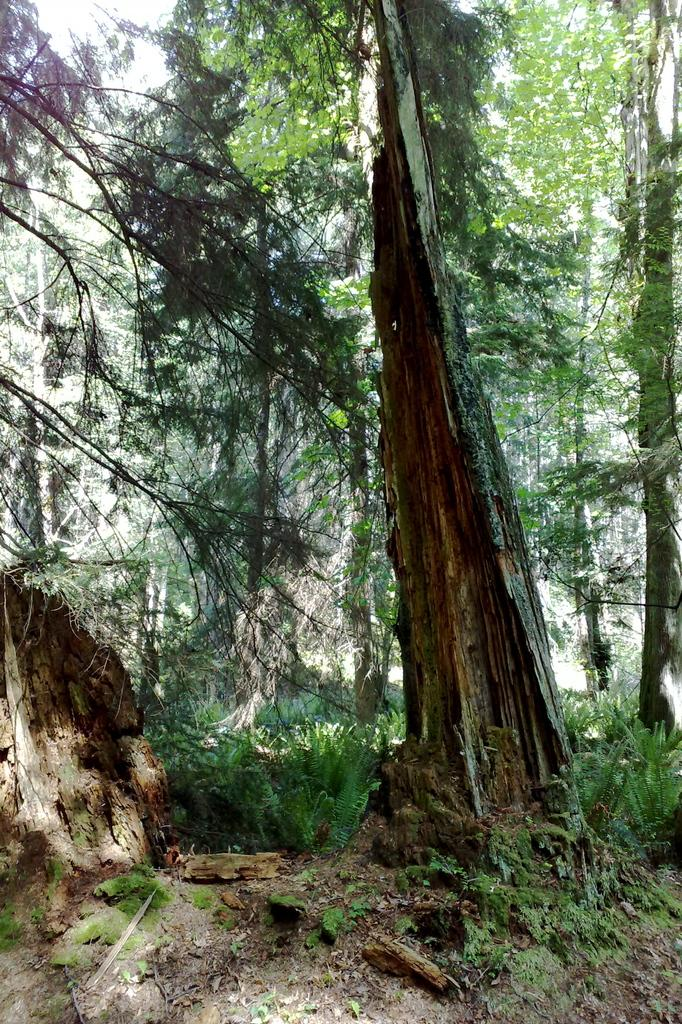What is the main object in the foreground of the image? The trunk of a tree is visible in the foreground. What is on the ground near the tree trunk? There are broken wooden pieces on the ground. What type of vegetation can be seen in the image? There are plants in the image. What can be seen in the background of the image? Trees are present in the background. What type of feather can be seen on the tail of the bird in the image? There is no bird or feather present in the image; it only features a tree trunk, broken wooden pieces, plants, and trees in the background. 